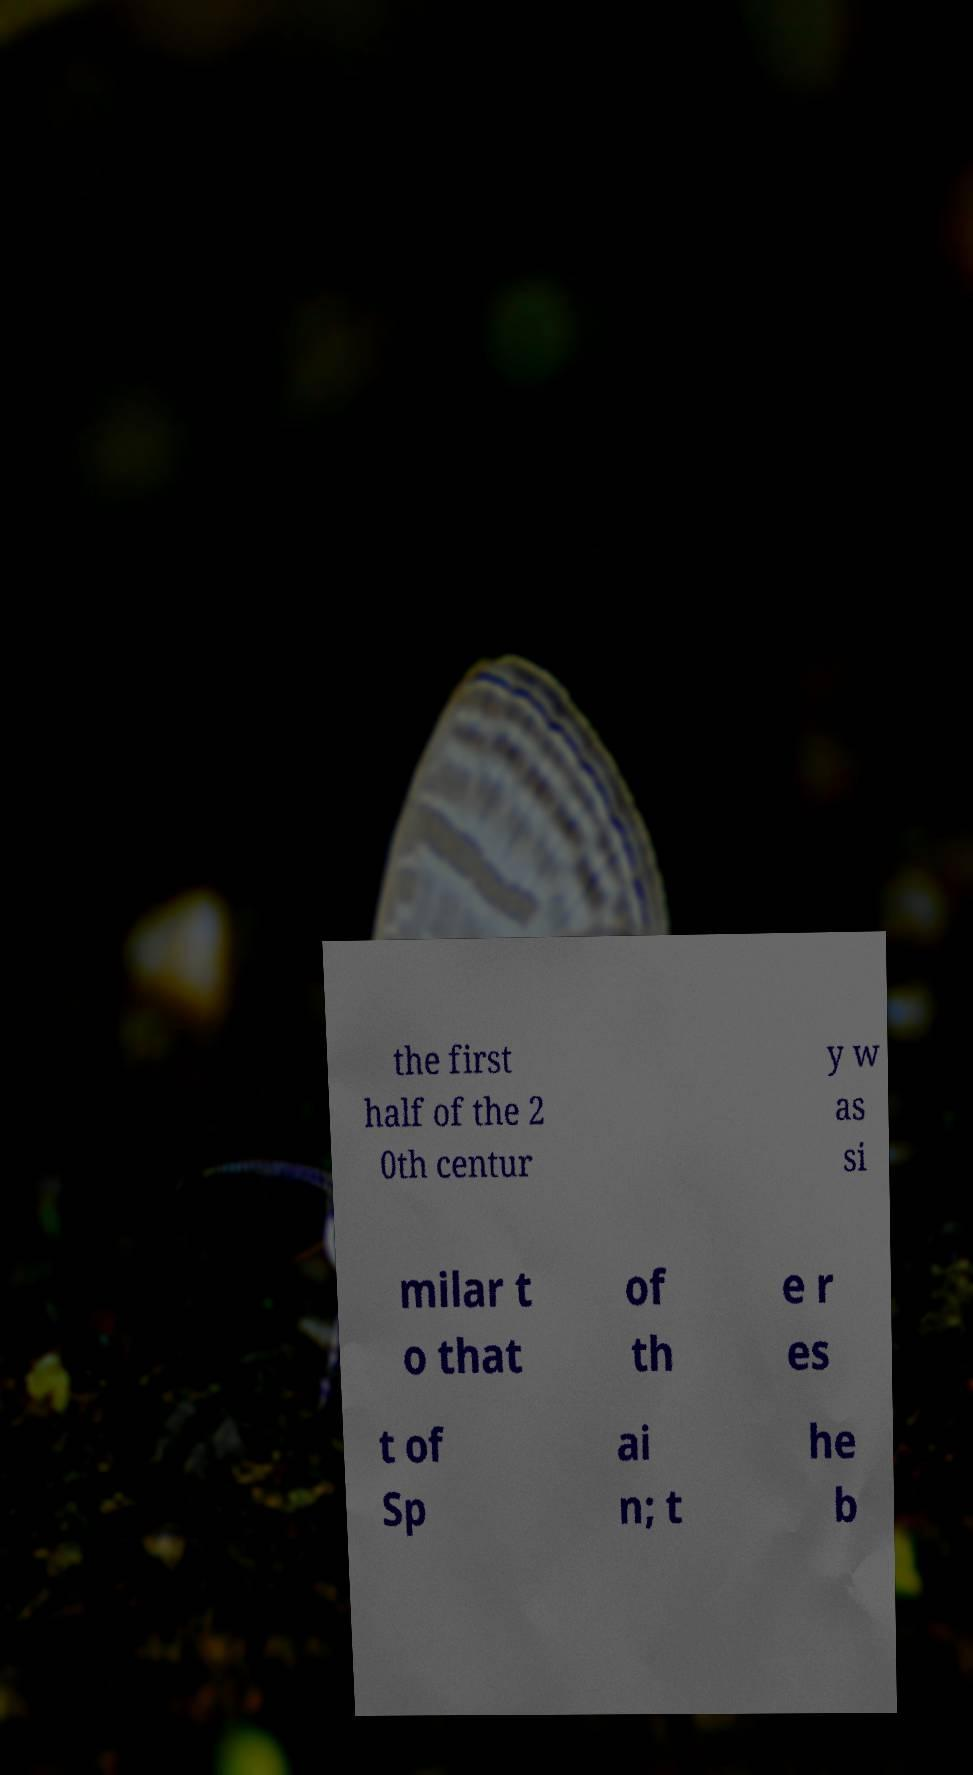Please identify and transcribe the text found in this image. the first half of the 2 0th centur y w as si milar t o that of th e r es t of Sp ai n; t he b 